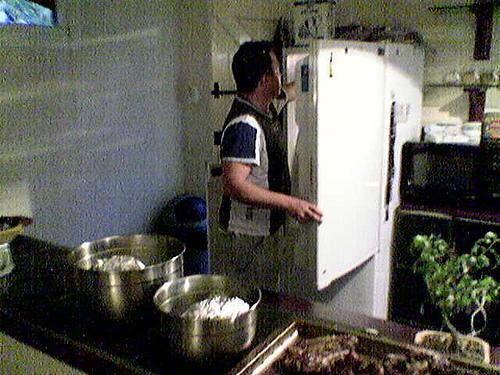What is the man touching?

Choices:
A) cat
B) apple
C) dog
D) refrigerator door refrigerator door 